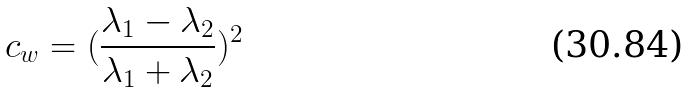Convert formula to latex. <formula><loc_0><loc_0><loc_500><loc_500>c _ { w } = ( \frac { \lambda _ { 1 } - \lambda _ { 2 } } { \lambda _ { 1 } + \lambda _ { 2 } } ) ^ { 2 }</formula> 